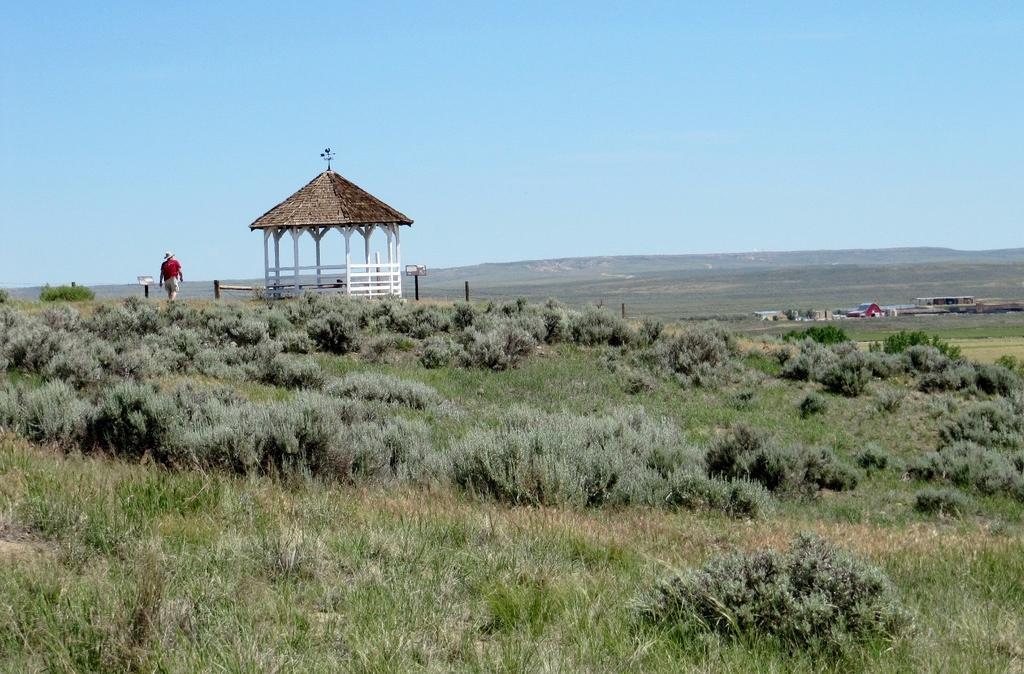Can you describe this image briefly? In this image I can see the grass. On the left side I can see a person and a hut. In the background, I can see the clouds in the sky. 